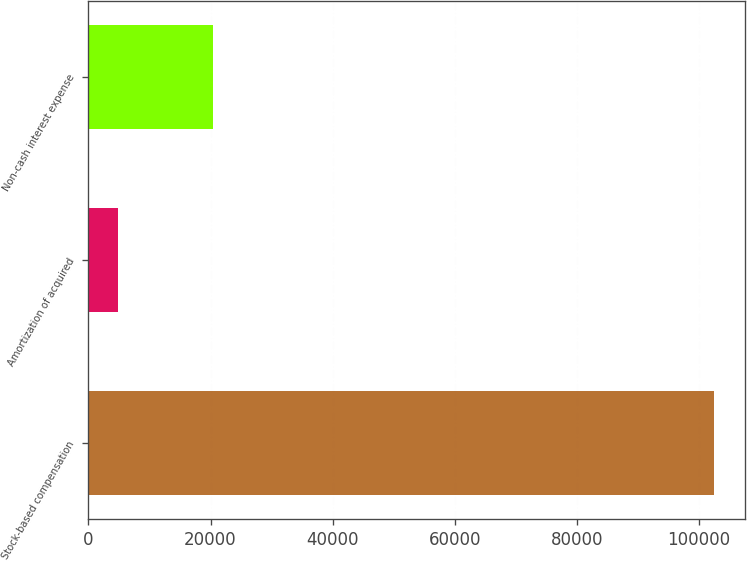<chart> <loc_0><loc_0><loc_500><loc_500><bar_chart><fcel>Stock-based compensation<fcel>Amortization of acquired<fcel>Non-cash interest expense<nl><fcel>102454<fcel>4929<fcel>20417<nl></chart> 